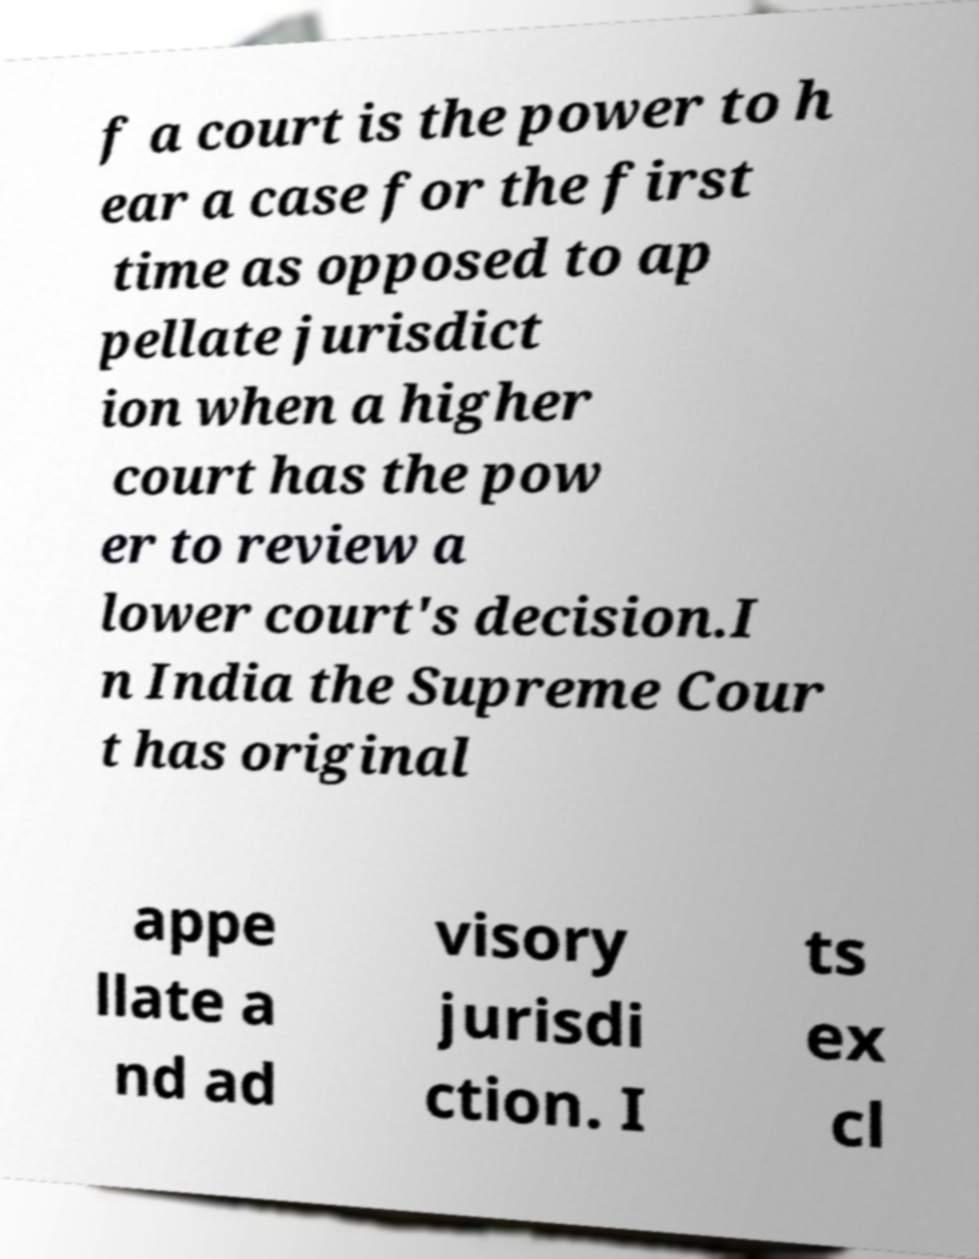Please identify and transcribe the text found in this image. f a court is the power to h ear a case for the first time as opposed to ap pellate jurisdict ion when a higher court has the pow er to review a lower court's decision.I n India the Supreme Cour t has original appe llate a nd ad visory jurisdi ction. I ts ex cl 